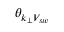<formula> <loc_0><loc_0><loc_500><loc_500>\theta _ { k _ { \perp } V _ { s w } }</formula> 